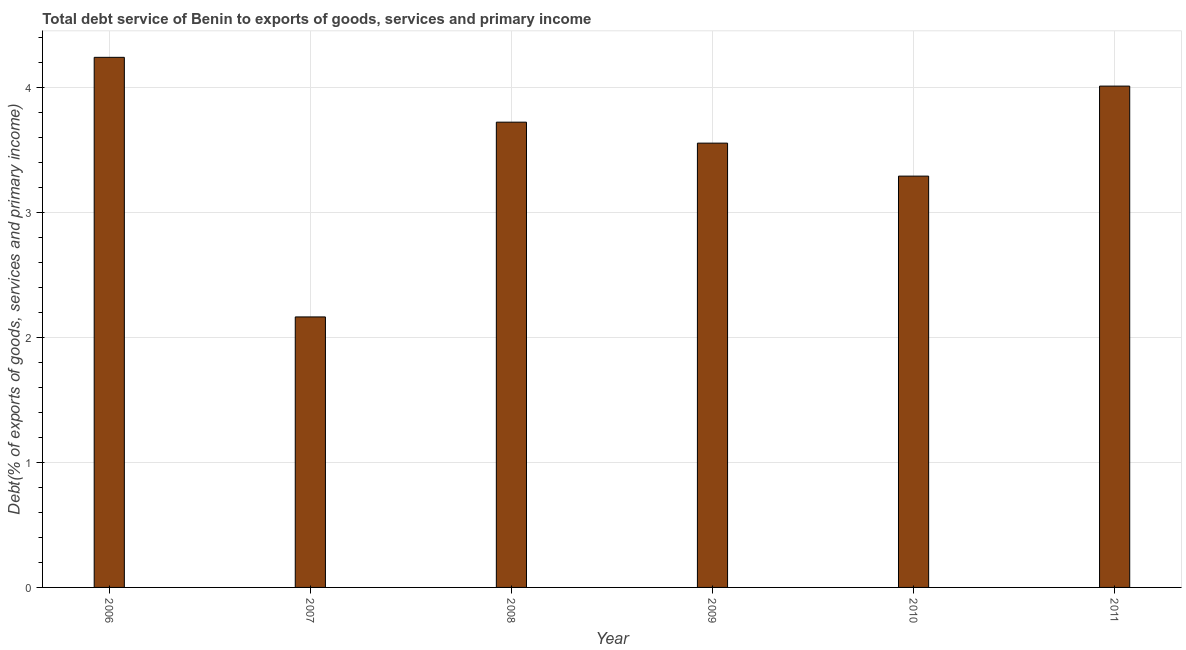Does the graph contain grids?
Ensure brevity in your answer.  Yes. What is the title of the graph?
Your response must be concise. Total debt service of Benin to exports of goods, services and primary income. What is the label or title of the X-axis?
Your response must be concise. Year. What is the label or title of the Y-axis?
Your answer should be compact. Debt(% of exports of goods, services and primary income). What is the total debt service in 2006?
Your response must be concise. 4.24. Across all years, what is the maximum total debt service?
Provide a succinct answer. 4.24. Across all years, what is the minimum total debt service?
Give a very brief answer. 2.17. What is the sum of the total debt service?
Keep it short and to the point. 21. What is the difference between the total debt service in 2009 and 2010?
Your answer should be compact. 0.26. What is the median total debt service?
Offer a terse response. 3.64. Do a majority of the years between 2008 and 2009 (inclusive) have total debt service greater than 2.2 %?
Your answer should be very brief. Yes. What is the ratio of the total debt service in 2007 to that in 2009?
Provide a succinct answer. 0.61. What is the difference between the highest and the second highest total debt service?
Give a very brief answer. 0.23. Is the sum of the total debt service in 2008 and 2009 greater than the maximum total debt service across all years?
Offer a very short reply. Yes. What is the difference between the highest and the lowest total debt service?
Ensure brevity in your answer.  2.08. Are all the bars in the graph horizontal?
Offer a terse response. No. What is the difference between two consecutive major ticks on the Y-axis?
Your response must be concise. 1. What is the Debt(% of exports of goods, services and primary income) in 2006?
Offer a very short reply. 4.24. What is the Debt(% of exports of goods, services and primary income) of 2007?
Provide a succinct answer. 2.17. What is the Debt(% of exports of goods, services and primary income) in 2008?
Your response must be concise. 3.72. What is the Debt(% of exports of goods, services and primary income) of 2009?
Your answer should be compact. 3.56. What is the Debt(% of exports of goods, services and primary income) of 2010?
Make the answer very short. 3.29. What is the Debt(% of exports of goods, services and primary income) in 2011?
Your answer should be very brief. 4.01. What is the difference between the Debt(% of exports of goods, services and primary income) in 2006 and 2007?
Offer a very short reply. 2.08. What is the difference between the Debt(% of exports of goods, services and primary income) in 2006 and 2008?
Give a very brief answer. 0.52. What is the difference between the Debt(% of exports of goods, services and primary income) in 2006 and 2009?
Your answer should be very brief. 0.69. What is the difference between the Debt(% of exports of goods, services and primary income) in 2006 and 2010?
Your answer should be compact. 0.95. What is the difference between the Debt(% of exports of goods, services and primary income) in 2006 and 2011?
Ensure brevity in your answer.  0.23. What is the difference between the Debt(% of exports of goods, services and primary income) in 2007 and 2008?
Offer a very short reply. -1.56. What is the difference between the Debt(% of exports of goods, services and primary income) in 2007 and 2009?
Ensure brevity in your answer.  -1.39. What is the difference between the Debt(% of exports of goods, services and primary income) in 2007 and 2010?
Make the answer very short. -1.13. What is the difference between the Debt(% of exports of goods, services and primary income) in 2007 and 2011?
Your answer should be compact. -1.85. What is the difference between the Debt(% of exports of goods, services and primary income) in 2008 and 2009?
Your answer should be very brief. 0.17. What is the difference between the Debt(% of exports of goods, services and primary income) in 2008 and 2010?
Provide a succinct answer. 0.43. What is the difference between the Debt(% of exports of goods, services and primary income) in 2008 and 2011?
Keep it short and to the point. -0.29. What is the difference between the Debt(% of exports of goods, services and primary income) in 2009 and 2010?
Offer a terse response. 0.26. What is the difference between the Debt(% of exports of goods, services and primary income) in 2009 and 2011?
Ensure brevity in your answer.  -0.46. What is the difference between the Debt(% of exports of goods, services and primary income) in 2010 and 2011?
Provide a succinct answer. -0.72. What is the ratio of the Debt(% of exports of goods, services and primary income) in 2006 to that in 2007?
Give a very brief answer. 1.96. What is the ratio of the Debt(% of exports of goods, services and primary income) in 2006 to that in 2008?
Give a very brief answer. 1.14. What is the ratio of the Debt(% of exports of goods, services and primary income) in 2006 to that in 2009?
Provide a succinct answer. 1.19. What is the ratio of the Debt(% of exports of goods, services and primary income) in 2006 to that in 2010?
Your answer should be very brief. 1.29. What is the ratio of the Debt(% of exports of goods, services and primary income) in 2006 to that in 2011?
Your answer should be compact. 1.06. What is the ratio of the Debt(% of exports of goods, services and primary income) in 2007 to that in 2008?
Make the answer very short. 0.58. What is the ratio of the Debt(% of exports of goods, services and primary income) in 2007 to that in 2009?
Offer a terse response. 0.61. What is the ratio of the Debt(% of exports of goods, services and primary income) in 2007 to that in 2010?
Your answer should be very brief. 0.66. What is the ratio of the Debt(% of exports of goods, services and primary income) in 2007 to that in 2011?
Keep it short and to the point. 0.54. What is the ratio of the Debt(% of exports of goods, services and primary income) in 2008 to that in 2009?
Keep it short and to the point. 1.05. What is the ratio of the Debt(% of exports of goods, services and primary income) in 2008 to that in 2010?
Your response must be concise. 1.13. What is the ratio of the Debt(% of exports of goods, services and primary income) in 2008 to that in 2011?
Provide a succinct answer. 0.93. What is the ratio of the Debt(% of exports of goods, services and primary income) in 2009 to that in 2010?
Your response must be concise. 1.08. What is the ratio of the Debt(% of exports of goods, services and primary income) in 2009 to that in 2011?
Provide a succinct answer. 0.89. What is the ratio of the Debt(% of exports of goods, services and primary income) in 2010 to that in 2011?
Provide a succinct answer. 0.82. 